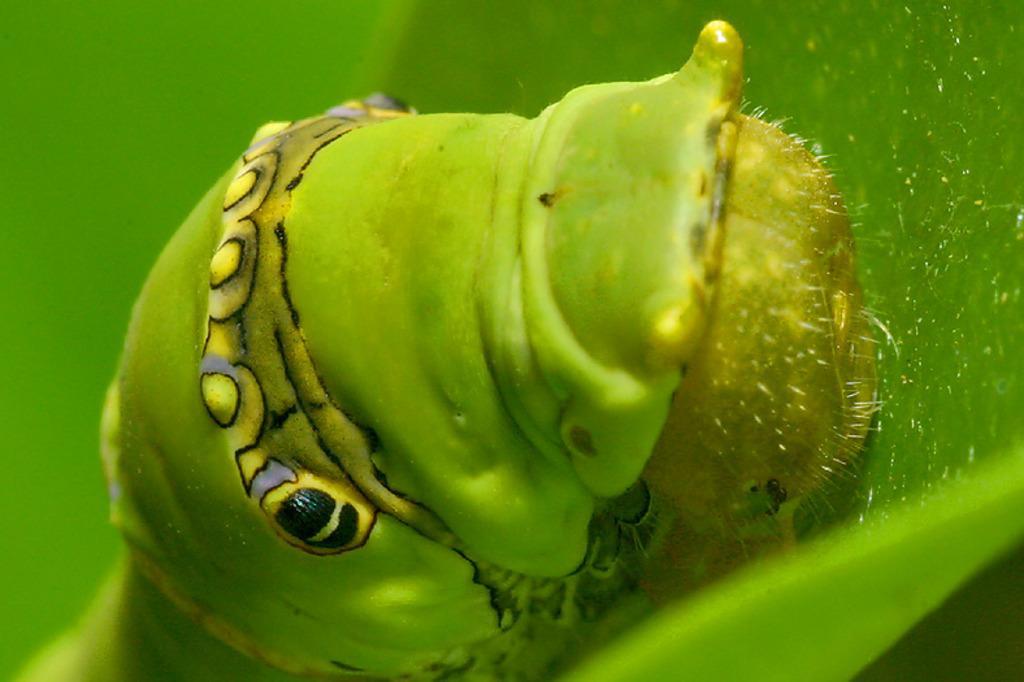Please provide a concise description of this image. In this image I can see a caterpillar which is green, yellow and black in color on the leaf which is green in color. 